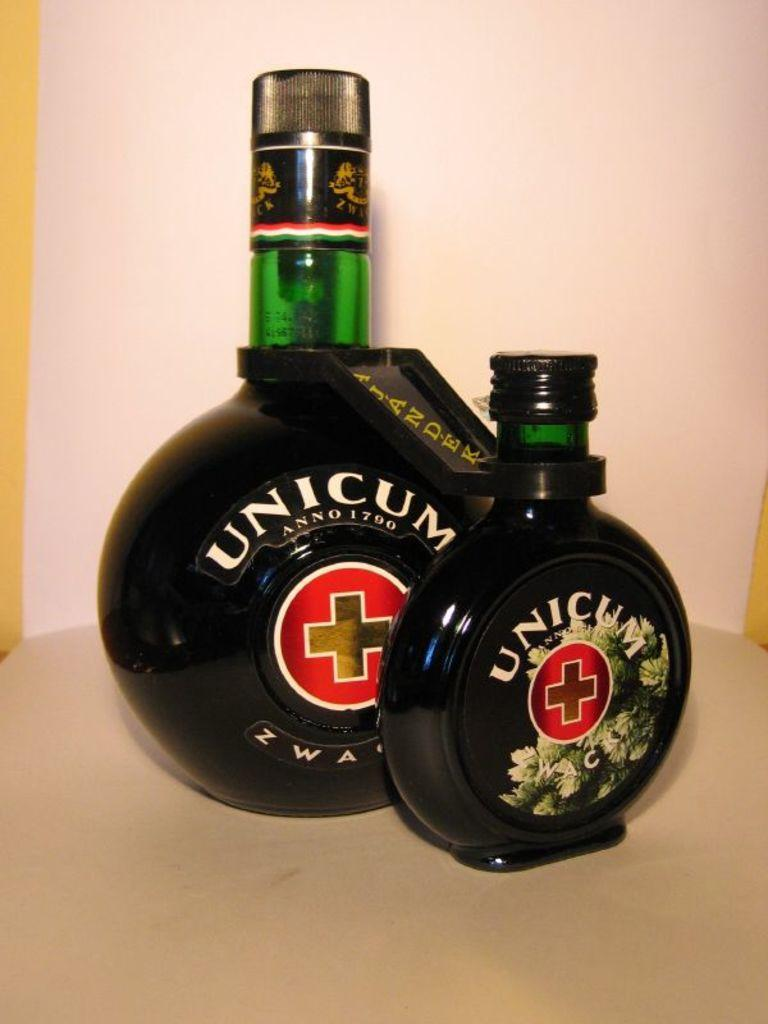<image>
Summarize the visual content of the image. A large bottle and a small bottle of Unicum alcohol. 